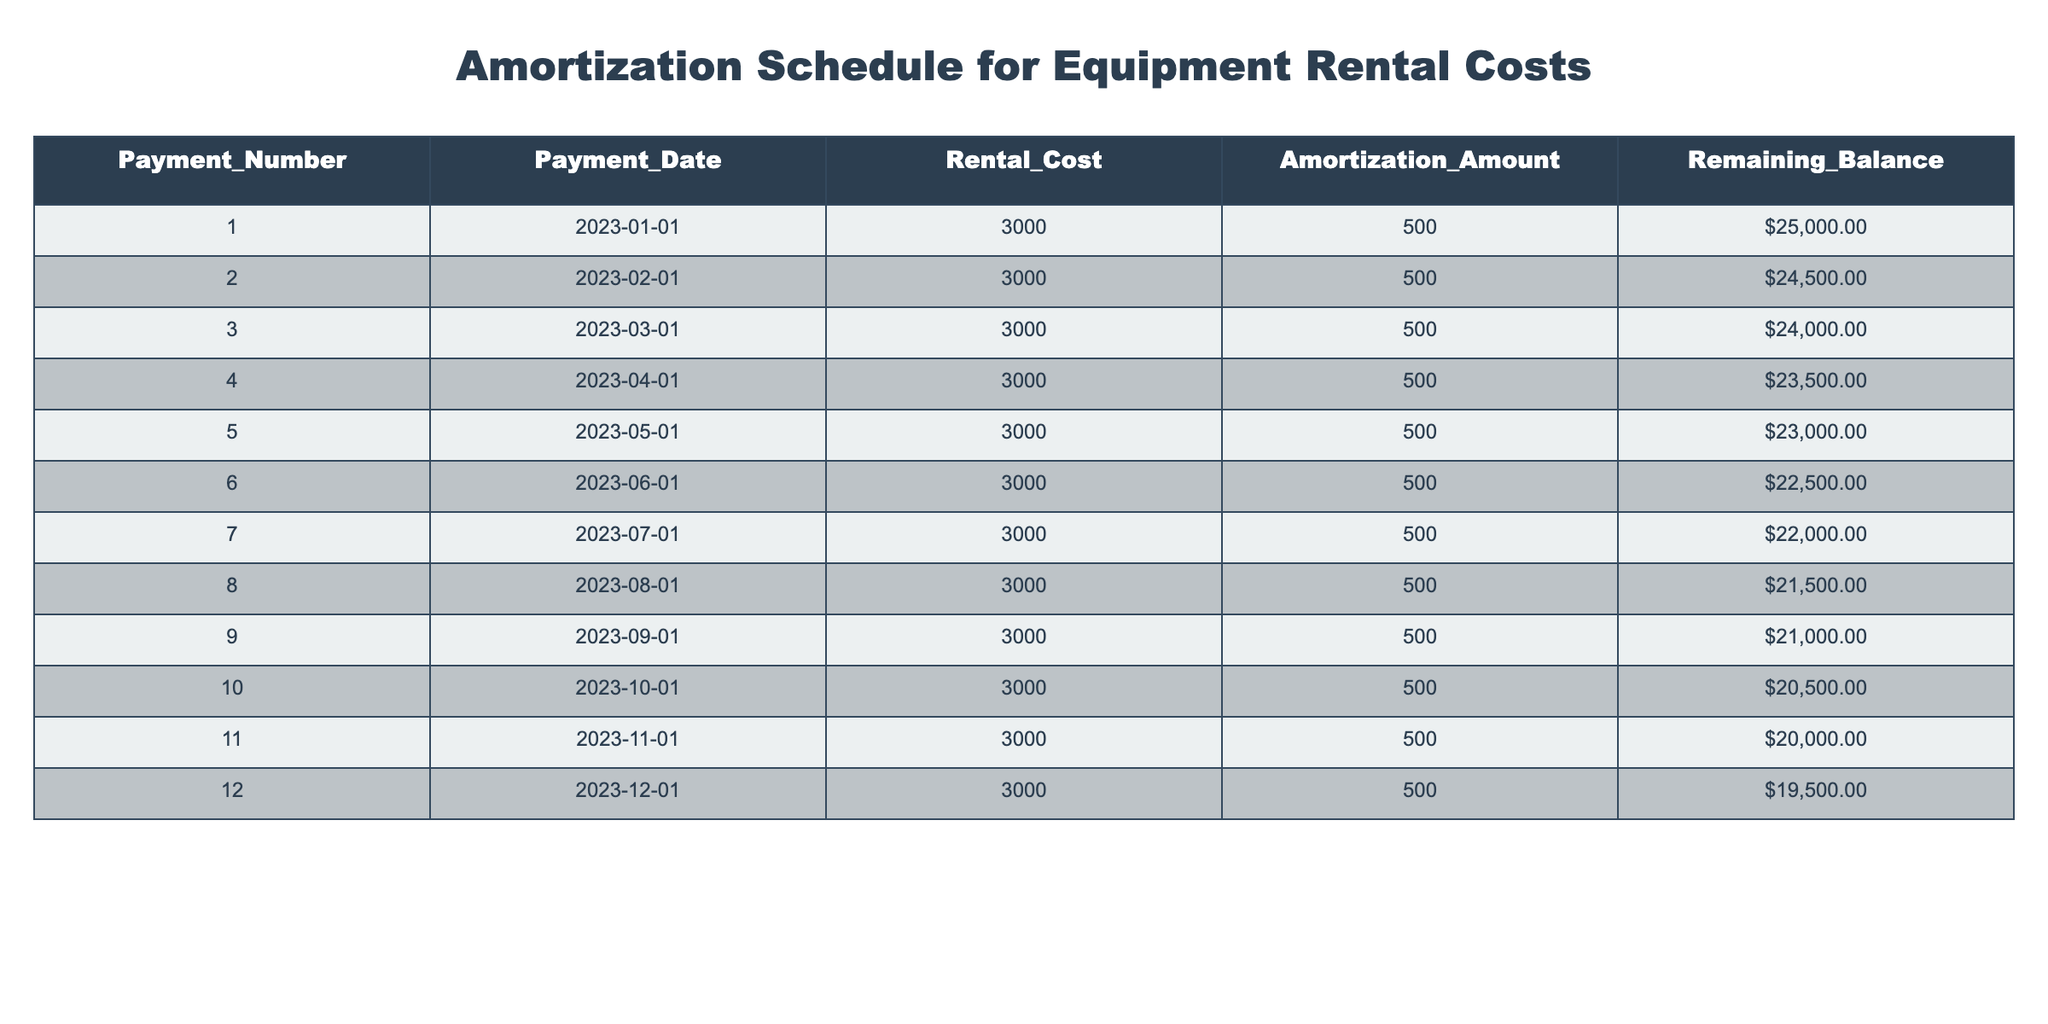What is the rental cost for the first payment? The table shows the rental cost for each payment under the "Rental_Cost" column. The first payment is listed as 3000.
Answer: 3000 What is the remaining balance after the fifth payment? To find the remaining balance after the fifth payment, we look at the "Remaining_Balance" column for row 5, which shows a remaining balance of 23000.
Answer: 23000 How much total has been amortized after the first three payments? The amortization amount for each payment can be found in the "Amortization_Amount" column. The sum for the first three payments is 500 + 500 + 500 = 1500.
Answer: 1500 Is the remaining balance lower than 20000 after the sixth payment? The remaining balance for the sixth payment is 22500, which is greater than 20000, therefore the answer is no.
Answer: No What is the average amortization amount per payment over the 12 payments? Since every payment has the same amortization amount of 500, the average is simply 500.
Answer: 500 How much total rental cost is paid by the end of the year? The rental cost for each of the 12 payments is consistently 3000. Therefore, the total rental cost paid is 3000 times 12, which equals 36000.
Answer: 36000 What is the remaining balance on the rental costs after the 10th payment? The remaining balance after the 10th payment is explicitly listed in the table, showing a value of 20500 in the "Remaining_Balance" column for the 10th payment.
Answer: 20500 What is the difference in remaining balance between the second and fourth payments? The remaining balance for the second payment is 24500 and for the fourth payment is 23500. The difference is 24500 - 23500 = 1000.
Answer: 1000 Does the rental cost change at any point during the payment schedule? The rental cost remains constantly at 3000 for each payment, indicating that there are no changes throughout the schedule.
Answer: No 